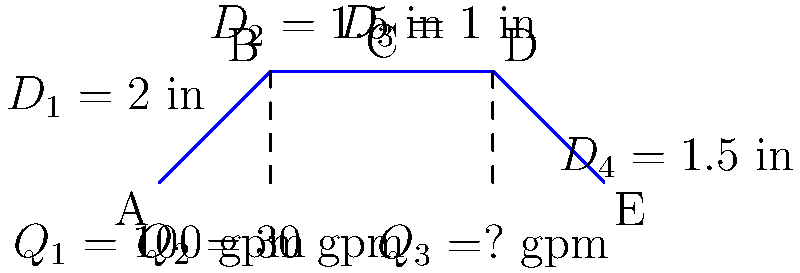A new housing development is being planned in a previously restricted area. The water supply system for this development includes a main pipe that branches into three smaller pipes. Given the pipe diameters and flow rates shown in the diagram, calculate the flow rate $Q_3$ in gallons per minute (gpm) exiting the system at point E. To solve this problem, we'll use the principle of conservation of mass, which states that the total flow rate entering the system must equal the total flow rate exiting the system.

Step 1: Identify the known flow rates and the unknown flow rate.
$Q_1 = 100$ gpm (entering the system)
$Q_2 = 30$ gpm (exiting at point B)
$Q_3 = $ unknown (exiting at point E)

Step 2: Set up the conservation of mass equation.
Total flow in = Total flow out
$Q_1 = Q_2 + Q_3$

Step 3: Substitute the known values and solve for $Q_3$.
$100 = 30 + Q_3$
$Q_3 = 100 - 30 = 70$ gpm

Therefore, the flow rate exiting the system at point E is 70 gpm.

Note: The pipe diameters provided in the diagram are not necessary for this calculation but could be useful for other types of flow analyses, such as determining pressure drops or flow velocities in each section.
Answer: 70 gpm 